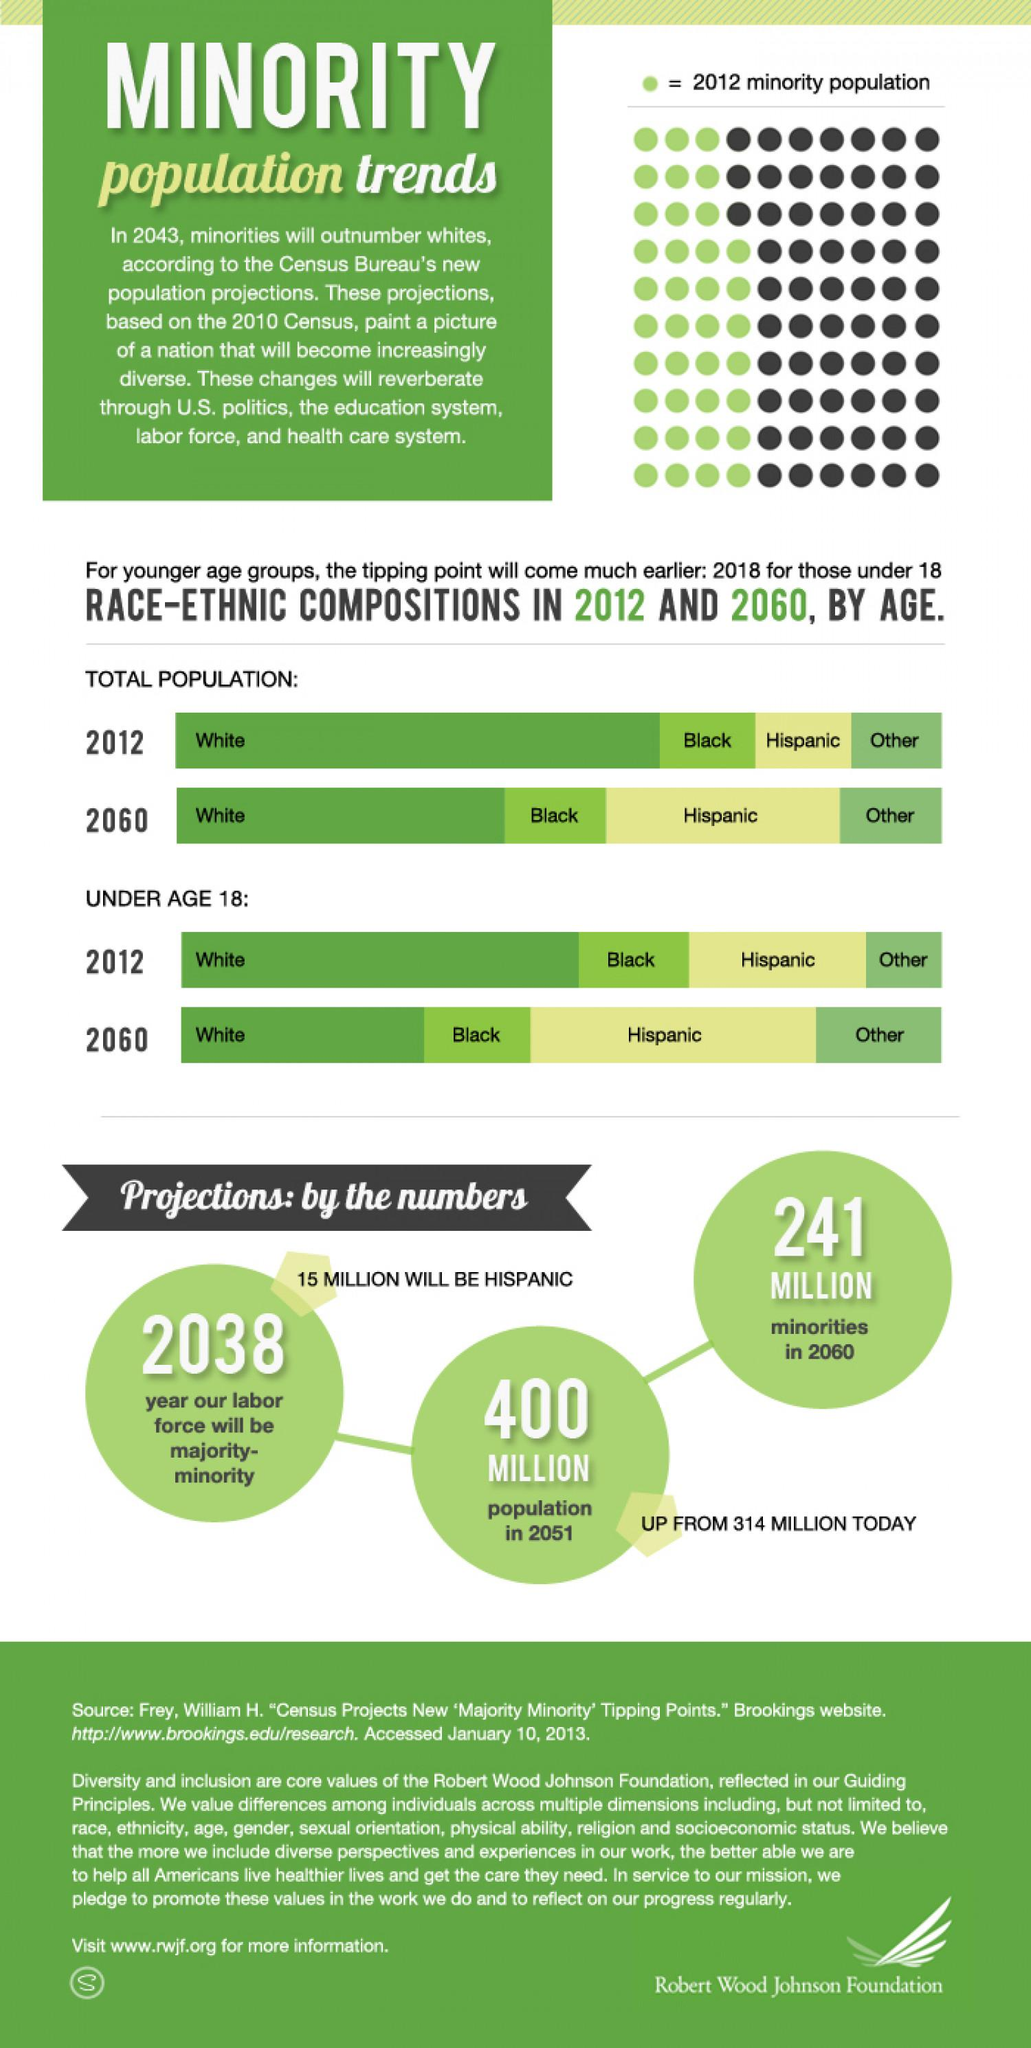Mention a couple of crucial points in this snapshot. The second-highest increase in population among individuals under 18 years old of all ethnic races is projected to occur by 2060. According to projections, the Hispanic ethnic race is expected to experience a significant increase in population by 2060. By 2060, the minority population is projected to increase by more than 50% of the majority population. According to projections, the white ethnic race is expected to experience a significant population decline by 2060. 